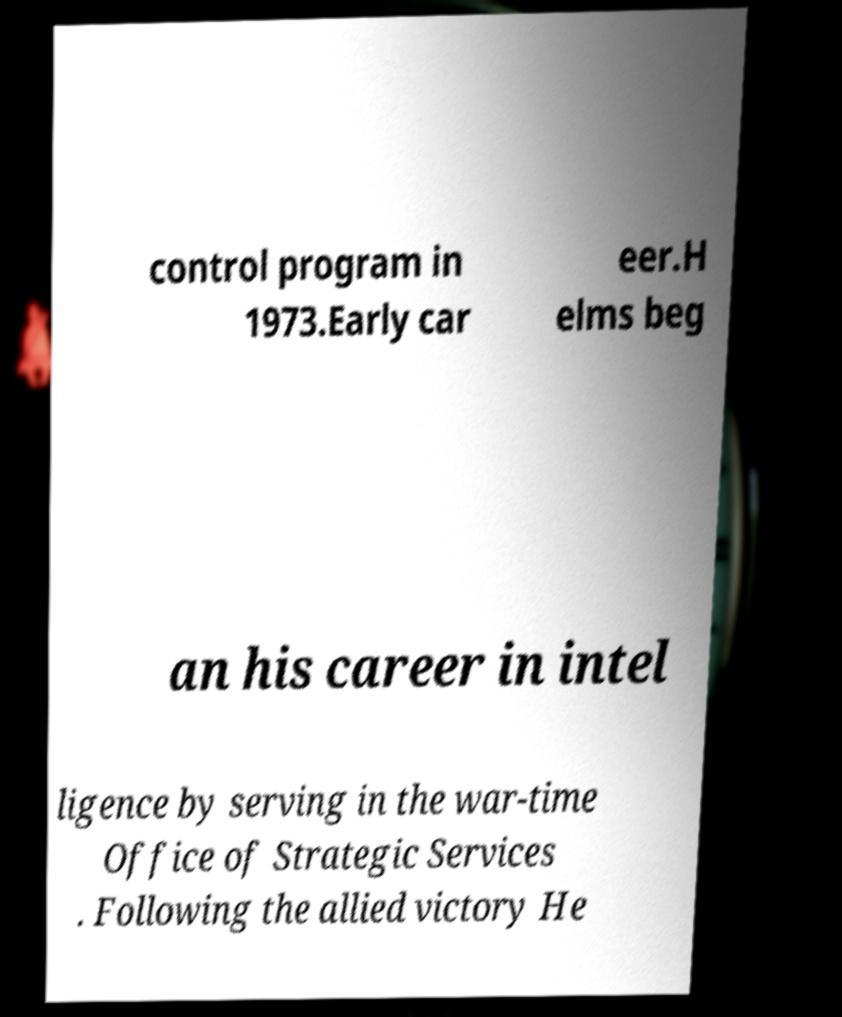There's text embedded in this image that I need extracted. Can you transcribe it verbatim? control program in 1973.Early car eer.H elms beg an his career in intel ligence by serving in the war-time Office of Strategic Services . Following the allied victory He 